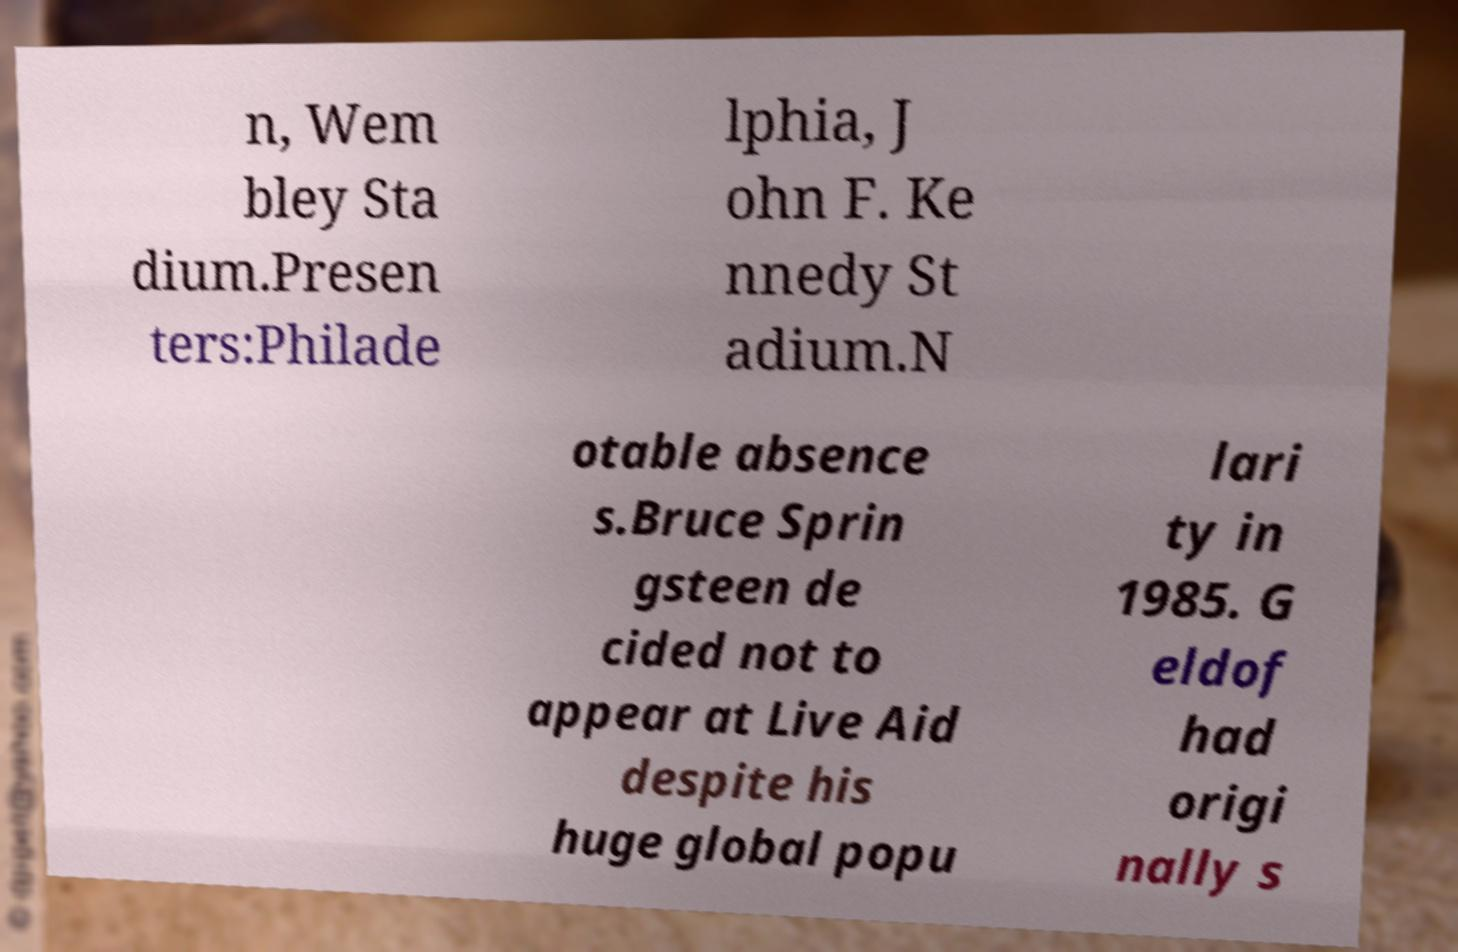Could you assist in decoding the text presented in this image and type it out clearly? n, Wem bley Sta dium.Presen ters:Philade lphia, J ohn F. Ke nnedy St adium.N otable absence s.Bruce Sprin gsteen de cided not to appear at Live Aid despite his huge global popu lari ty in 1985. G eldof had origi nally s 